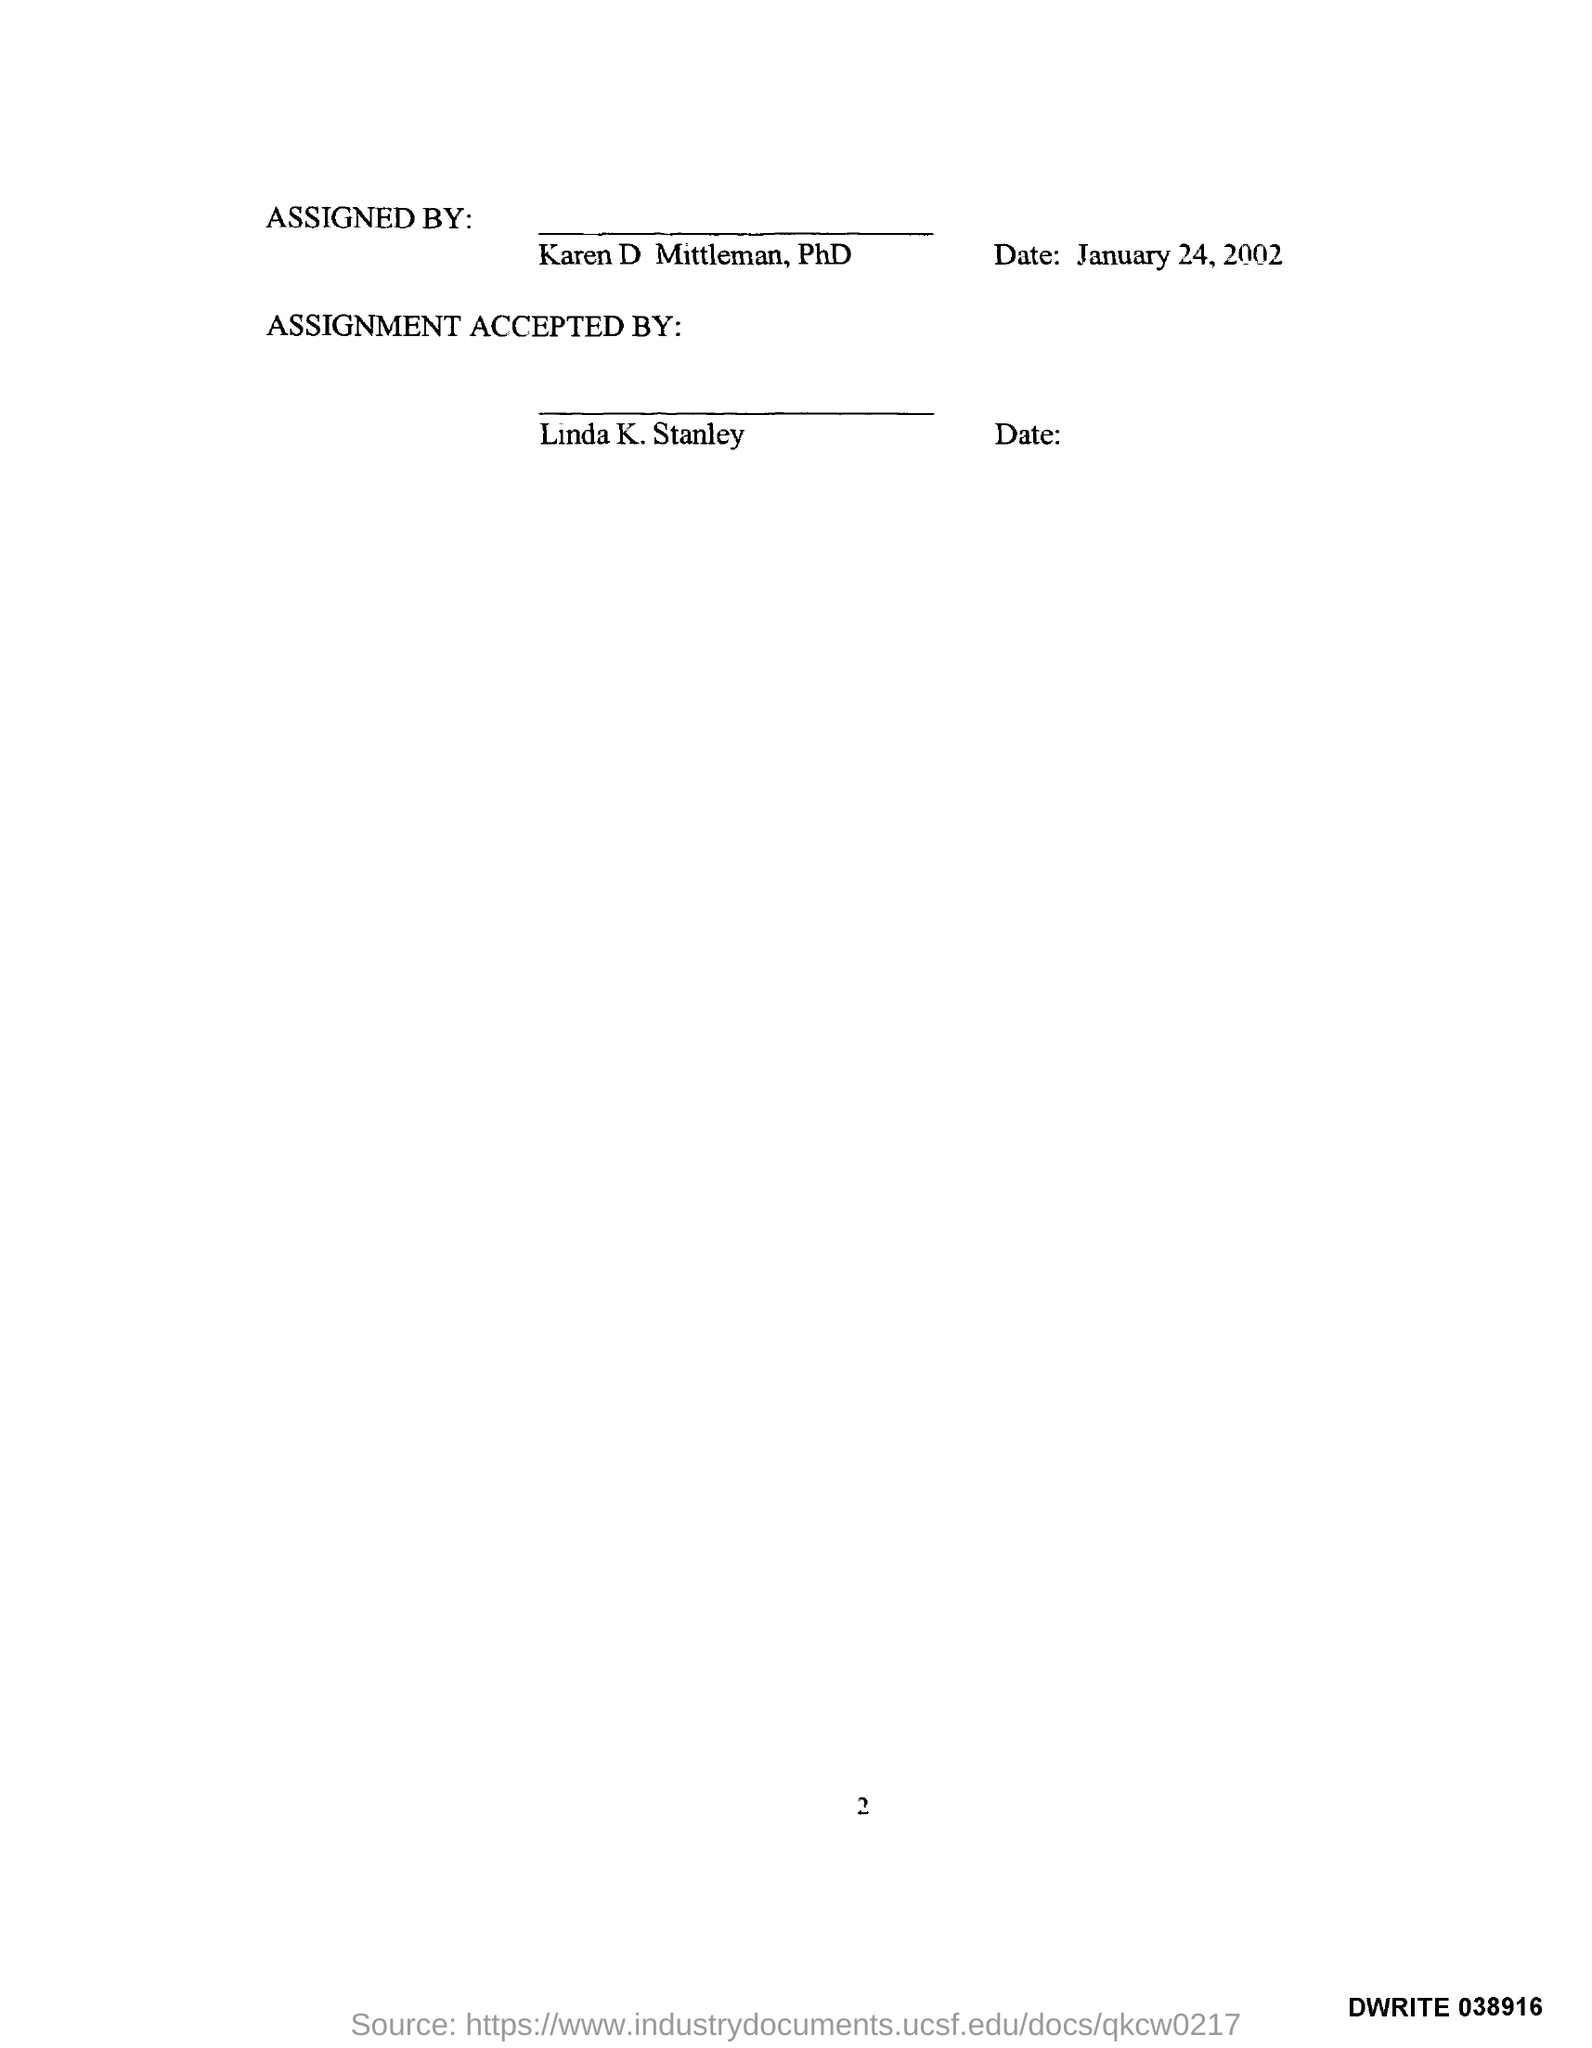Who accepted the assignment on this document? The assignment was accepted by Linda K. Stanley, as indicated by the name written below the 'ASSIGNMENT ACCEPTED BY:' section. Is there a date specified for when Linda K. Stanley accepted the assignment? No, the date of acceptance is not filled in; it is left blank next to Linda K. Stanley's name. 